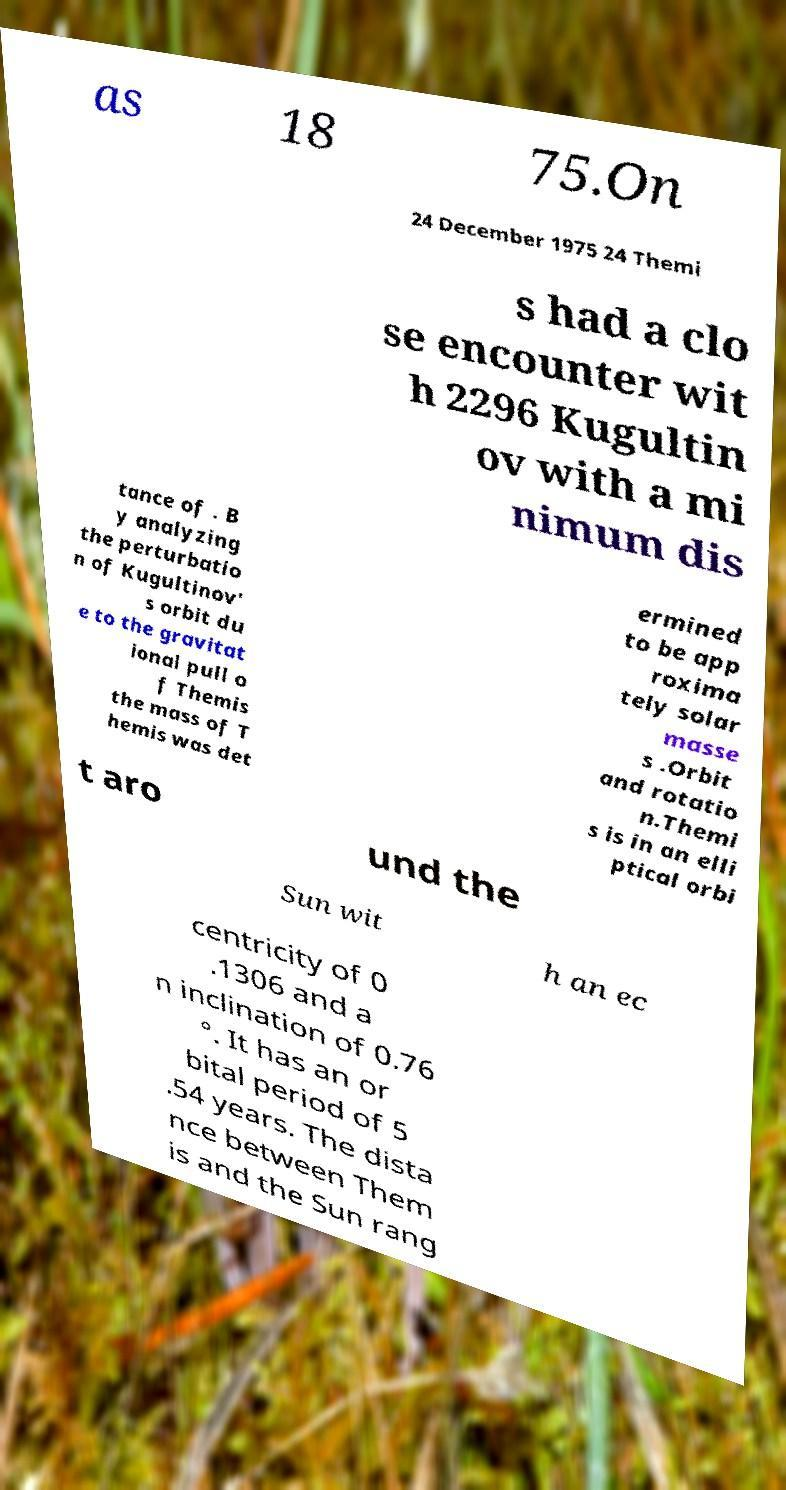What messages or text are displayed in this image? I need them in a readable, typed format. as 18 75.On 24 December 1975 24 Themi s had a clo se encounter wit h 2296 Kugultin ov with a mi nimum dis tance of . B y analyzing the perturbatio n of Kugultinov' s orbit du e to the gravitat ional pull o f Themis the mass of T hemis was det ermined to be app roxima tely solar masse s .Orbit and rotatio n.Themi s is in an elli ptical orbi t aro und the Sun wit h an ec centricity of 0 .1306 and a n inclination of 0.76 °. It has an or bital period of 5 .54 years. The dista nce between Them is and the Sun rang 